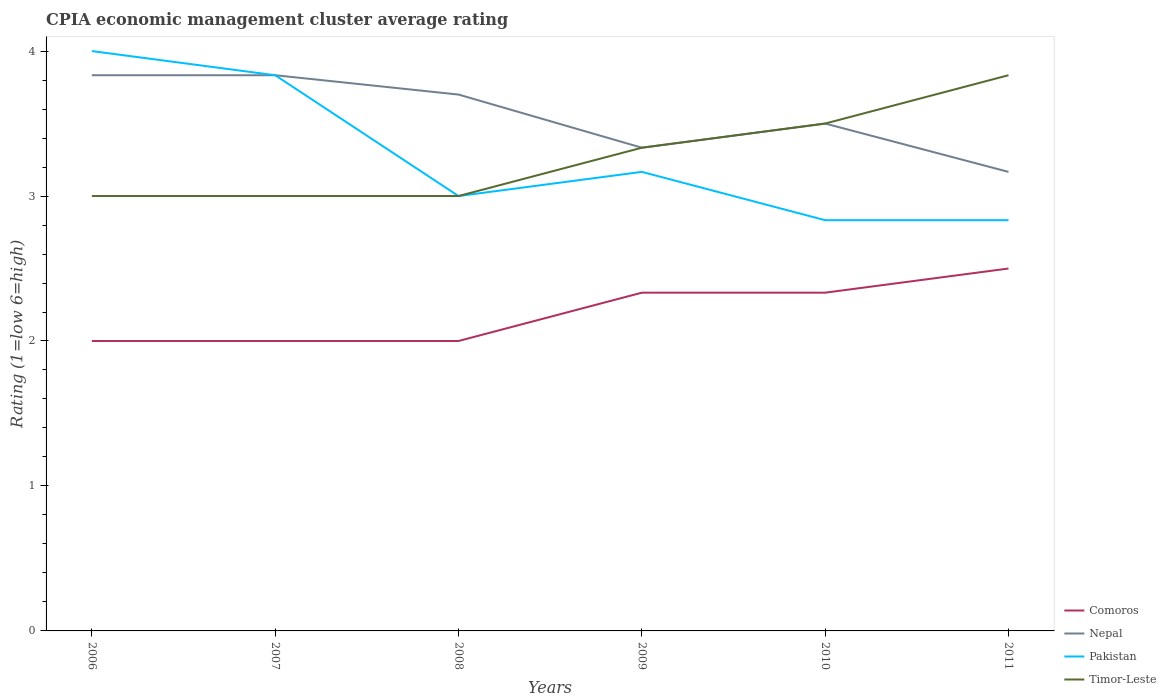How many different coloured lines are there?
Provide a short and direct response. 4. Across all years, what is the maximum CPIA rating in Pakistan?
Ensure brevity in your answer.  2.83. What is the total CPIA rating in Comoros in the graph?
Your answer should be very brief. -0.17. What is the difference between the highest and the second highest CPIA rating in Timor-Leste?
Keep it short and to the point. 0.83. What is the difference between the highest and the lowest CPIA rating in Nepal?
Ensure brevity in your answer.  3. Is the CPIA rating in Pakistan strictly greater than the CPIA rating in Nepal over the years?
Keep it short and to the point. No. Does the graph contain grids?
Keep it short and to the point. No. Where does the legend appear in the graph?
Give a very brief answer. Bottom right. How are the legend labels stacked?
Your answer should be very brief. Vertical. What is the title of the graph?
Your response must be concise. CPIA economic management cluster average rating. What is the label or title of the X-axis?
Offer a very short reply. Years. What is the label or title of the Y-axis?
Ensure brevity in your answer.  Rating (1=low 6=high). What is the Rating (1=low 6=high) of Comoros in 2006?
Your answer should be compact. 2. What is the Rating (1=low 6=high) in Nepal in 2006?
Your answer should be compact. 3.83. What is the Rating (1=low 6=high) of Nepal in 2007?
Your answer should be compact. 3.83. What is the Rating (1=low 6=high) in Pakistan in 2007?
Give a very brief answer. 3.83. What is the Rating (1=low 6=high) of Timor-Leste in 2007?
Keep it short and to the point. 3. What is the Rating (1=low 6=high) of Comoros in 2008?
Ensure brevity in your answer.  2. What is the Rating (1=low 6=high) in Pakistan in 2008?
Your response must be concise. 3. What is the Rating (1=low 6=high) in Timor-Leste in 2008?
Ensure brevity in your answer.  3. What is the Rating (1=low 6=high) in Comoros in 2009?
Offer a terse response. 2.33. What is the Rating (1=low 6=high) of Nepal in 2009?
Provide a short and direct response. 3.33. What is the Rating (1=low 6=high) in Pakistan in 2009?
Offer a terse response. 3.17. What is the Rating (1=low 6=high) of Timor-Leste in 2009?
Your answer should be compact. 3.33. What is the Rating (1=low 6=high) of Comoros in 2010?
Keep it short and to the point. 2.33. What is the Rating (1=low 6=high) in Pakistan in 2010?
Provide a succinct answer. 2.83. What is the Rating (1=low 6=high) in Timor-Leste in 2010?
Offer a terse response. 3.5. What is the Rating (1=low 6=high) in Nepal in 2011?
Provide a short and direct response. 3.17. What is the Rating (1=low 6=high) in Pakistan in 2011?
Provide a short and direct response. 2.83. What is the Rating (1=low 6=high) of Timor-Leste in 2011?
Provide a short and direct response. 3.83. Across all years, what is the maximum Rating (1=low 6=high) in Nepal?
Offer a terse response. 3.83. Across all years, what is the maximum Rating (1=low 6=high) in Pakistan?
Provide a short and direct response. 4. Across all years, what is the maximum Rating (1=low 6=high) in Timor-Leste?
Your answer should be very brief. 3.83. Across all years, what is the minimum Rating (1=low 6=high) of Comoros?
Offer a terse response. 2. Across all years, what is the minimum Rating (1=low 6=high) in Nepal?
Offer a terse response. 3.17. Across all years, what is the minimum Rating (1=low 6=high) of Pakistan?
Your answer should be very brief. 2.83. Across all years, what is the minimum Rating (1=low 6=high) of Timor-Leste?
Offer a terse response. 3. What is the total Rating (1=low 6=high) in Comoros in the graph?
Give a very brief answer. 13.17. What is the total Rating (1=low 6=high) in Nepal in the graph?
Your answer should be compact. 21.37. What is the total Rating (1=low 6=high) of Pakistan in the graph?
Offer a very short reply. 19.67. What is the total Rating (1=low 6=high) in Timor-Leste in the graph?
Offer a very short reply. 19.67. What is the difference between the Rating (1=low 6=high) of Comoros in 2006 and that in 2007?
Ensure brevity in your answer.  0. What is the difference between the Rating (1=low 6=high) of Nepal in 2006 and that in 2007?
Ensure brevity in your answer.  0. What is the difference between the Rating (1=low 6=high) in Pakistan in 2006 and that in 2007?
Your answer should be compact. 0.17. What is the difference between the Rating (1=low 6=high) of Timor-Leste in 2006 and that in 2007?
Your answer should be very brief. 0. What is the difference between the Rating (1=low 6=high) of Comoros in 2006 and that in 2008?
Offer a terse response. 0. What is the difference between the Rating (1=low 6=high) in Nepal in 2006 and that in 2008?
Keep it short and to the point. 0.13. What is the difference between the Rating (1=low 6=high) in Pakistan in 2006 and that in 2008?
Your response must be concise. 1. What is the difference between the Rating (1=low 6=high) of Pakistan in 2006 and that in 2009?
Your answer should be very brief. 0.83. What is the difference between the Rating (1=low 6=high) in Timor-Leste in 2006 and that in 2009?
Give a very brief answer. -0.33. What is the difference between the Rating (1=low 6=high) in Nepal in 2006 and that in 2010?
Ensure brevity in your answer.  0.33. What is the difference between the Rating (1=low 6=high) of Timor-Leste in 2006 and that in 2010?
Give a very brief answer. -0.5. What is the difference between the Rating (1=low 6=high) of Timor-Leste in 2006 and that in 2011?
Your answer should be compact. -0.83. What is the difference between the Rating (1=low 6=high) in Nepal in 2007 and that in 2008?
Your response must be concise. 0.13. What is the difference between the Rating (1=low 6=high) of Nepal in 2007 and that in 2009?
Provide a short and direct response. 0.5. What is the difference between the Rating (1=low 6=high) in Pakistan in 2007 and that in 2009?
Your answer should be very brief. 0.67. What is the difference between the Rating (1=low 6=high) in Comoros in 2007 and that in 2010?
Keep it short and to the point. -0.33. What is the difference between the Rating (1=low 6=high) of Nepal in 2007 and that in 2010?
Your response must be concise. 0.33. What is the difference between the Rating (1=low 6=high) in Timor-Leste in 2007 and that in 2010?
Provide a short and direct response. -0.5. What is the difference between the Rating (1=low 6=high) of Comoros in 2007 and that in 2011?
Your response must be concise. -0.5. What is the difference between the Rating (1=low 6=high) in Timor-Leste in 2007 and that in 2011?
Ensure brevity in your answer.  -0.83. What is the difference between the Rating (1=low 6=high) in Comoros in 2008 and that in 2009?
Ensure brevity in your answer.  -0.33. What is the difference between the Rating (1=low 6=high) of Nepal in 2008 and that in 2009?
Ensure brevity in your answer.  0.37. What is the difference between the Rating (1=low 6=high) in Pakistan in 2008 and that in 2009?
Keep it short and to the point. -0.17. What is the difference between the Rating (1=low 6=high) in Comoros in 2008 and that in 2010?
Keep it short and to the point. -0.33. What is the difference between the Rating (1=low 6=high) in Pakistan in 2008 and that in 2010?
Make the answer very short. 0.17. What is the difference between the Rating (1=low 6=high) of Timor-Leste in 2008 and that in 2010?
Provide a succinct answer. -0.5. What is the difference between the Rating (1=low 6=high) of Nepal in 2008 and that in 2011?
Provide a succinct answer. 0.53. What is the difference between the Rating (1=low 6=high) in Timor-Leste in 2008 and that in 2011?
Give a very brief answer. -0.83. What is the difference between the Rating (1=low 6=high) in Nepal in 2009 and that in 2010?
Your answer should be very brief. -0.17. What is the difference between the Rating (1=low 6=high) of Pakistan in 2009 and that in 2010?
Your answer should be compact. 0.33. What is the difference between the Rating (1=low 6=high) of Timor-Leste in 2009 and that in 2010?
Ensure brevity in your answer.  -0.17. What is the difference between the Rating (1=low 6=high) in Nepal in 2009 and that in 2011?
Offer a terse response. 0.17. What is the difference between the Rating (1=low 6=high) of Pakistan in 2009 and that in 2011?
Your answer should be very brief. 0.33. What is the difference between the Rating (1=low 6=high) in Comoros in 2010 and that in 2011?
Your answer should be very brief. -0.17. What is the difference between the Rating (1=low 6=high) of Nepal in 2010 and that in 2011?
Your response must be concise. 0.33. What is the difference between the Rating (1=low 6=high) in Pakistan in 2010 and that in 2011?
Offer a terse response. 0. What is the difference between the Rating (1=low 6=high) of Timor-Leste in 2010 and that in 2011?
Your response must be concise. -0.33. What is the difference between the Rating (1=low 6=high) of Comoros in 2006 and the Rating (1=low 6=high) of Nepal in 2007?
Make the answer very short. -1.83. What is the difference between the Rating (1=low 6=high) of Comoros in 2006 and the Rating (1=low 6=high) of Pakistan in 2007?
Ensure brevity in your answer.  -1.83. What is the difference between the Rating (1=low 6=high) in Pakistan in 2006 and the Rating (1=low 6=high) in Timor-Leste in 2007?
Your answer should be compact. 1. What is the difference between the Rating (1=low 6=high) of Comoros in 2006 and the Rating (1=low 6=high) of Pakistan in 2008?
Keep it short and to the point. -1. What is the difference between the Rating (1=low 6=high) in Comoros in 2006 and the Rating (1=low 6=high) in Timor-Leste in 2008?
Give a very brief answer. -1. What is the difference between the Rating (1=low 6=high) in Nepal in 2006 and the Rating (1=low 6=high) in Pakistan in 2008?
Keep it short and to the point. 0.83. What is the difference between the Rating (1=low 6=high) of Pakistan in 2006 and the Rating (1=low 6=high) of Timor-Leste in 2008?
Offer a terse response. 1. What is the difference between the Rating (1=low 6=high) of Comoros in 2006 and the Rating (1=low 6=high) of Nepal in 2009?
Your response must be concise. -1.33. What is the difference between the Rating (1=low 6=high) in Comoros in 2006 and the Rating (1=low 6=high) in Pakistan in 2009?
Make the answer very short. -1.17. What is the difference between the Rating (1=low 6=high) of Comoros in 2006 and the Rating (1=low 6=high) of Timor-Leste in 2009?
Make the answer very short. -1.33. What is the difference between the Rating (1=low 6=high) in Nepal in 2006 and the Rating (1=low 6=high) in Pakistan in 2009?
Ensure brevity in your answer.  0.67. What is the difference between the Rating (1=low 6=high) of Comoros in 2006 and the Rating (1=low 6=high) of Nepal in 2010?
Your response must be concise. -1.5. What is the difference between the Rating (1=low 6=high) of Comoros in 2006 and the Rating (1=low 6=high) of Pakistan in 2010?
Provide a short and direct response. -0.83. What is the difference between the Rating (1=low 6=high) of Nepal in 2006 and the Rating (1=low 6=high) of Pakistan in 2010?
Your response must be concise. 1. What is the difference between the Rating (1=low 6=high) in Nepal in 2006 and the Rating (1=low 6=high) in Timor-Leste in 2010?
Provide a short and direct response. 0.33. What is the difference between the Rating (1=low 6=high) of Pakistan in 2006 and the Rating (1=low 6=high) of Timor-Leste in 2010?
Your answer should be compact. 0.5. What is the difference between the Rating (1=low 6=high) of Comoros in 2006 and the Rating (1=low 6=high) of Nepal in 2011?
Your answer should be very brief. -1.17. What is the difference between the Rating (1=low 6=high) in Comoros in 2006 and the Rating (1=low 6=high) in Pakistan in 2011?
Your response must be concise. -0.83. What is the difference between the Rating (1=low 6=high) of Comoros in 2006 and the Rating (1=low 6=high) of Timor-Leste in 2011?
Offer a terse response. -1.83. What is the difference between the Rating (1=low 6=high) of Nepal in 2006 and the Rating (1=low 6=high) of Pakistan in 2011?
Keep it short and to the point. 1. What is the difference between the Rating (1=low 6=high) of Pakistan in 2006 and the Rating (1=low 6=high) of Timor-Leste in 2011?
Ensure brevity in your answer.  0.17. What is the difference between the Rating (1=low 6=high) of Comoros in 2007 and the Rating (1=low 6=high) of Timor-Leste in 2008?
Your answer should be compact. -1. What is the difference between the Rating (1=low 6=high) of Nepal in 2007 and the Rating (1=low 6=high) of Pakistan in 2008?
Keep it short and to the point. 0.83. What is the difference between the Rating (1=low 6=high) of Comoros in 2007 and the Rating (1=low 6=high) of Nepal in 2009?
Your answer should be very brief. -1.33. What is the difference between the Rating (1=low 6=high) in Comoros in 2007 and the Rating (1=low 6=high) in Pakistan in 2009?
Give a very brief answer. -1.17. What is the difference between the Rating (1=low 6=high) in Comoros in 2007 and the Rating (1=low 6=high) in Timor-Leste in 2009?
Provide a short and direct response. -1.33. What is the difference between the Rating (1=low 6=high) in Nepal in 2007 and the Rating (1=low 6=high) in Pakistan in 2009?
Ensure brevity in your answer.  0.67. What is the difference between the Rating (1=low 6=high) of Nepal in 2007 and the Rating (1=low 6=high) of Timor-Leste in 2009?
Make the answer very short. 0.5. What is the difference between the Rating (1=low 6=high) in Pakistan in 2007 and the Rating (1=low 6=high) in Timor-Leste in 2009?
Provide a succinct answer. 0.5. What is the difference between the Rating (1=low 6=high) of Nepal in 2007 and the Rating (1=low 6=high) of Pakistan in 2010?
Provide a succinct answer. 1. What is the difference between the Rating (1=low 6=high) of Nepal in 2007 and the Rating (1=low 6=high) of Timor-Leste in 2010?
Provide a short and direct response. 0.33. What is the difference between the Rating (1=low 6=high) in Comoros in 2007 and the Rating (1=low 6=high) in Nepal in 2011?
Offer a very short reply. -1.17. What is the difference between the Rating (1=low 6=high) of Comoros in 2007 and the Rating (1=low 6=high) of Pakistan in 2011?
Keep it short and to the point. -0.83. What is the difference between the Rating (1=low 6=high) of Comoros in 2007 and the Rating (1=low 6=high) of Timor-Leste in 2011?
Your answer should be very brief. -1.83. What is the difference between the Rating (1=low 6=high) of Pakistan in 2007 and the Rating (1=low 6=high) of Timor-Leste in 2011?
Your answer should be compact. 0. What is the difference between the Rating (1=low 6=high) of Comoros in 2008 and the Rating (1=low 6=high) of Nepal in 2009?
Offer a terse response. -1.33. What is the difference between the Rating (1=low 6=high) in Comoros in 2008 and the Rating (1=low 6=high) in Pakistan in 2009?
Your answer should be very brief. -1.17. What is the difference between the Rating (1=low 6=high) of Comoros in 2008 and the Rating (1=low 6=high) of Timor-Leste in 2009?
Offer a terse response. -1.33. What is the difference between the Rating (1=low 6=high) in Nepal in 2008 and the Rating (1=low 6=high) in Pakistan in 2009?
Provide a short and direct response. 0.53. What is the difference between the Rating (1=low 6=high) of Nepal in 2008 and the Rating (1=low 6=high) of Timor-Leste in 2009?
Keep it short and to the point. 0.37. What is the difference between the Rating (1=low 6=high) of Pakistan in 2008 and the Rating (1=low 6=high) of Timor-Leste in 2009?
Make the answer very short. -0.33. What is the difference between the Rating (1=low 6=high) in Comoros in 2008 and the Rating (1=low 6=high) in Nepal in 2010?
Make the answer very short. -1.5. What is the difference between the Rating (1=low 6=high) in Nepal in 2008 and the Rating (1=low 6=high) in Pakistan in 2010?
Provide a succinct answer. 0.87. What is the difference between the Rating (1=low 6=high) in Nepal in 2008 and the Rating (1=low 6=high) in Timor-Leste in 2010?
Your answer should be compact. 0.2. What is the difference between the Rating (1=low 6=high) in Pakistan in 2008 and the Rating (1=low 6=high) in Timor-Leste in 2010?
Ensure brevity in your answer.  -0.5. What is the difference between the Rating (1=low 6=high) in Comoros in 2008 and the Rating (1=low 6=high) in Nepal in 2011?
Offer a terse response. -1.17. What is the difference between the Rating (1=low 6=high) of Comoros in 2008 and the Rating (1=low 6=high) of Timor-Leste in 2011?
Offer a terse response. -1.83. What is the difference between the Rating (1=low 6=high) of Nepal in 2008 and the Rating (1=low 6=high) of Pakistan in 2011?
Give a very brief answer. 0.87. What is the difference between the Rating (1=low 6=high) of Nepal in 2008 and the Rating (1=low 6=high) of Timor-Leste in 2011?
Give a very brief answer. -0.13. What is the difference between the Rating (1=low 6=high) in Pakistan in 2008 and the Rating (1=low 6=high) in Timor-Leste in 2011?
Offer a terse response. -0.83. What is the difference between the Rating (1=low 6=high) of Comoros in 2009 and the Rating (1=low 6=high) of Nepal in 2010?
Your answer should be compact. -1.17. What is the difference between the Rating (1=low 6=high) in Comoros in 2009 and the Rating (1=low 6=high) in Timor-Leste in 2010?
Make the answer very short. -1.17. What is the difference between the Rating (1=low 6=high) of Nepal in 2009 and the Rating (1=low 6=high) of Pakistan in 2010?
Keep it short and to the point. 0.5. What is the difference between the Rating (1=low 6=high) of Nepal in 2009 and the Rating (1=low 6=high) of Timor-Leste in 2010?
Ensure brevity in your answer.  -0.17. What is the difference between the Rating (1=low 6=high) of Pakistan in 2009 and the Rating (1=low 6=high) of Timor-Leste in 2011?
Provide a succinct answer. -0.67. What is the difference between the Rating (1=low 6=high) in Comoros in 2010 and the Rating (1=low 6=high) in Timor-Leste in 2011?
Your answer should be compact. -1.5. What is the difference between the Rating (1=low 6=high) of Nepal in 2010 and the Rating (1=low 6=high) of Pakistan in 2011?
Provide a short and direct response. 0.67. What is the difference between the Rating (1=low 6=high) of Nepal in 2010 and the Rating (1=low 6=high) of Timor-Leste in 2011?
Offer a terse response. -0.33. What is the average Rating (1=low 6=high) of Comoros per year?
Provide a succinct answer. 2.19. What is the average Rating (1=low 6=high) of Nepal per year?
Offer a very short reply. 3.56. What is the average Rating (1=low 6=high) of Pakistan per year?
Your answer should be very brief. 3.28. What is the average Rating (1=low 6=high) in Timor-Leste per year?
Offer a very short reply. 3.28. In the year 2006, what is the difference between the Rating (1=low 6=high) of Comoros and Rating (1=low 6=high) of Nepal?
Your answer should be very brief. -1.83. In the year 2006, what is the difference between the Rating (1=low 6=high) of Comoros and Rating (1=low 6=high) of Pakistan?
Your response must be concise. -2. In the year 2006, what is the difference between the Rating (1=low 6=high) in Comoros and Rating (1=low 6=high) in Timor-Leste?
Offer a terse response. -1. In the year 2006, what is the difference between the Rating (1=low 6=high) of Nepal and Rating (1=low 6=high) of Timor-Leste?
Provide a succinct answer. 0.83. In the year 2006, what is the difference between the Rating (1=low 6=high) of Pakistan and Rating (1=low 6=high) of Timor-Leste?
Offer a very short reply. 1. In the year 2007, what is the difference between the Rating (1=low 6=high) in Comoros and Rating (1=low 6=high) in Nepal?
Ensure brevity in your answer.  -1.83. In the year 2007, what is the difference between the Rating (1=low 6=high) in Comoros and Rating (1=low 6=high) in Pakistan?
Keep it short and to the point. -1.83. In the year 2008, what is the difference between the Rating (1=low 6=high) of Comoros and Rating (1=low 6=high) of Nepal?
Your answer should be compact. -1.7. In the year 2008, what is the difference between the Rating (1=low 6=high) of Comoros and Rating (1=low 6=high) of Pakistan?
Ensure brevity in your answer.  -1. In the year 2009, what is the difference between the Rating (1=low 6=high) in Comoros and Rating (1=low 6=high) in Nepal?
Make the answer very short. -1. In the year 2009, what is the difference between the Rating (1=low 6=high) of Comoros and Rating (1=low 6=high) of Pakistan?
Make the answer very short. -0.83. In the year 2009, what is the difference between the Rating (1=low 6=high) in Pakistan and Rating (1=low 6=high) in Timor-Leste?
Provide a succinct answer. -0.17. In the year 2010, what is the difference between the Rating (1=low 6=high) of Comoros and Rating (1=low 6=high) of Nepal?
Ensure brevity in your answer.  -1.17. In the year 2010, what is the difference between the Rating (1=low 6=high) in Comoros and Rating (1=low 6=high) in Timor-Leste?
Provide a short and direct response. -1.17. In the year 2010, what is the difference between the Rating (1=low 6=high) in Nepal and Rating (1=low 6=high) in Pakistan?
Provide a short and direct response. 0.67. In the year 2010, what is the difference between the Rating (1=low 6=high) of Nepal and Rating (1=low 6=high) of Timor-Leste?
Keep it short and to the point. 0. In the year 2011, what is the difference between the Rating (1=low 6=high) of Comoros and Rating (1=low 6=high) of Nepal?
Provide a succinct answer. -0.67. In the year 2011, what is the difference between the Rating (1=low 6=high) of Comoros and Rating (1=low 6=high) of Pakistan?
Provide a succinct answer. -0.33. In the year 2011, what is the difference between the Rating (1=low 6=high) of Comoros and Rating (1=low 6=high) of Timor-Leste?
Make the answer very short. -1.33. In the year 2011, what is the difference between the Rating (1=low 6=high) in Nepal and Rating (1=low 6=high) in Timor-Leste?
Ensure brevity in your answer.  -0.67. In the year 2011, what is the difference between the Rating (1=low 6=high) of Pakistan and Rating (1=low 6=high) of Timor-Leste?
Your answer should be compact. -1. What is the ratio of the Rating (1=low 6=high) in Comoros in 2006 to that in 2007?
Keep it short and to the point. 1. What is the ratio of the Rating (1=low 6=high) in Pakistan in 2006 to that in 2007?
Your answer should be very brief. 1.04. What is the ratio of the Rating (1=low 6=high) of Comoros in 2006 to that in 2008?
Your response must be concise. 1. What is the ratio of the Rating (1=low 6=high) in Nepal in 2006 to that in 2008?
Keep it short and to the point. 1.04. What is the ratio of the Rating (1=low 6=high) of Comoros in 2006 to that in 2009?
Provide a succinct answer. 0.86. What is the ratio of the Rating (1=low 6=high) in Nepal in 2006 to that in 2009?
Your answer should be compact. 1.15. What is the ratio of the Rating (1=low 6=high) in Pakistan in 2006 to that in 2009?
Offer a very short reply. 1.26. What is the ratio of the Rating (1=low 6=high) of Timor-Leste in 2006 to that in 2009?
Give a very brief answer. 0.9. What is the ratio of the Rating (1=low 6=high) of Comoros in 2006 to that in 2010?
Your response must be concise. 0.86. What is the ratio of the Rating (1=low 6=high) in Nepal in 2006 to that in 2010?
Provide a short and direct response. 1.1. What is the ratio of the Rating (1=low 6=high) in Pakistan in 2006 to that in 2010?
Provide a succinct answer. 1.41. What is the ratio of the Rating (1=low 6=high) of Timor-Leste in 2006 to that in 2010?
Offer a very short reply. 0.86. What is the ratio of the Rating (1=low 6=high) in Nepal in 2006 to that in 2011?
Offer a very short reply. 1.21. What is the ratio of the Rating (1=low 6=high) of Pakistan in 2006 to that in 2011?
Your response must be concise. 1.41. What is the ratio of the Rating (1=low 6=high) in Timor-Leste in 2006 to that in 2011?
Your answer should be very brief. 0.78. What is the ratio of the Rating (1=low 6=high) in Comoros in 2007 to that in 2008?
Ensure brevity in your answer.  1. What is the ratio of the Rating (1=low 6=high) in Nepal in 2007 to that in 2008?
Make the answer very short. 1.04. What is the ratio of the Rating (1=low 6=high) in Pakistan in 2007 to that in 2008?
Ensure brevity in your answer.  1.28. What is the ratio of the Rating (1=low 6=high) of Timor-Leste in 2007 to that in 2008?
Your answer should be very brief. 1. What is the ratio of the Rating (1=low 6=high) of Comoros in 2007 to that in 2009?
Your answer should be compact. 0.86. What is the ratio of the Rating (1=low 6=high) in Nepal in 2007 to that in 2009?
Keep it short and to the point. 1.15. What is the ratio of the Rating (1=low 6=high) of Pakistan in 2007 to that in 2009?
Offer a terse response. 1.21. What is the ratio of the Rating (1=low 6=high) in Timor-Leste in 2007 to that in 2009?
Keep it short and to the point. 0.9. What is the ratio of the Rating (1=low 6=high) of Comoros in 2007 to that in 2010?
Offer a terse response. 0.86. What is the ratio of the Rating (1=low 6=high) in Nepal in 2007 to that in 2010?
Your answer should be very brief. 1.1. What is the ratio of the Rating (1=low 6=high) in Pakistan in 2007 to that in 2010?
Provide a short and direct response. 1.35. What is the ratio of the Rating (1=low 6=high) of Timor-Leste in 2007 to that in 2010?
Keep it short and to the point. 0.86. What is the ratio of the Rating (1=low 6=high) in Nepal in 2007 to that in 2011?
Provide a short and direct response. 1.21. What is the ratio of the Rating (1=low 6=high) of Pakistan in 2007 to that in 2011?
Your answer should be very brief. 1.35. What is the ratio of the Rating (1=low 6=high) of Timor-Leste in 2007 to that in 2011?
Your response must be concise. 0.78. What is the ratio of the Rating (1=low 6=high) of Nepal in 2008 to that in 2009?
Your response must be concise. 1.11. What is the ratio of the Rating (1=low 6=high) in Pakistan in 2008 to that in 2009?
Offer a terse response. 0.95. What is the ratio of the Rating (1=low 6=high) of Comoros in 2008 to that in 2010?
Make the answer very short. 0.86. What is the ratio of the Rating (1=low 6=high) in Nepal in 2008 to that in 2010?
Your answer should be compact. 1.06. What is the ratio of the Rating (1=low 6=high) in Pakistan in 2008 to that in 2010?
Offer a terse response. 1.06. What is the ratio of the Rating (1=low 6=high) of Nepal in 2008 to that in 2011?
Offer a terse response. 1.17. What is the ratio of the Rating (1=low 6=high) of Pakistan in 2008 to that in 2011?
Offer a very short reply. 1.06. What is the ratio of the Rating (1=low 6=high) of Timor-Leste in 2008 to that in 2011?
Offer a terse response. 0.78. What is the ratio of the Rating (1=low 6=high) of Comoros in 2009 to that in 2010?
Give a very brief answer. 1. What is the ratio of the Rating (1=low 6=high) in Nepal in 2009 to that in 2010?
Your answer should be compact. 0.95. What is the ratio of the Rating (1=low 6=high) of Pakistan in 2009 to that in 2010?
Your answer should be compact. 1.12. What is the ratio of the Rating (1=low 6=high) in Nepal in 2009 to that in 2011?
Make the answer very short. 1.05. What is the ratio of the Rating (1=low 6=high) in Pakistan in 2009 to that in 2011?
Your answer should be very brief. 1.12. What is the ratio of the Rating (1=low 6=high) of Timor-Leste in 2009 to that in 2011?
Ensure brevity in your answer.  0.87. What is the ratio of the Rating (1=low 6=high) in Nepal in 2010 to that in 2011?
Your answer should be compact. 1.11. What is the ratio of the Rating (1=low 6=high) in Timor-Leste in 2010 to that in 2011?
Your response must be concise. 0.91. What is the difference between the highest and the second highest Rating (1=low 6=high) in Timor-Leste?
Ensure brevity in your answer.  0.33. What is the difference between the highest and the lowest Rating (1=low 6=high) of Pakistan?
Provide a short and direct response. 1.17. 